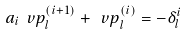Convert formula to latex. <formula><loc_0><loc_0><loc_500><loc_500>a _ { i } \ v p _ { l } ^ { ( i + 1 ) } + \ v p _ { l } ^ { ( i ) } = - \delta _ { l } ^ { i }</formula> 